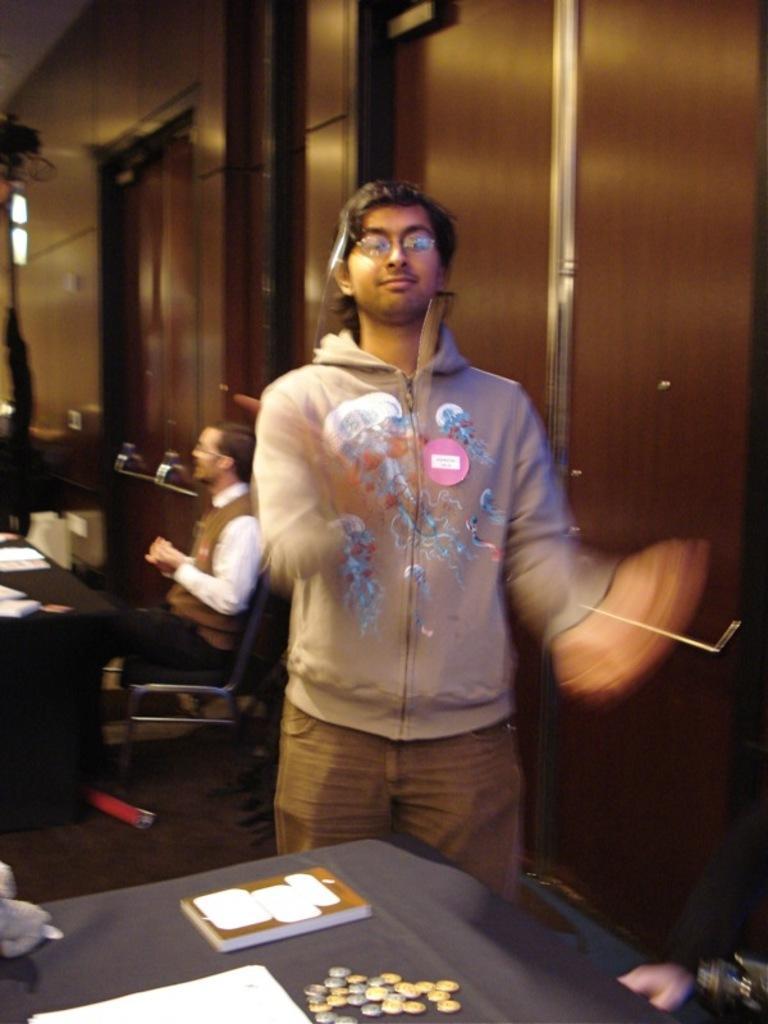Describe this image in one or two sentences. In this image I can see a person standing wearing gray color shirt, brown pant. In front I can see few papers, coins on the table. Background I can see a person sitting and cupboards in brown color. 